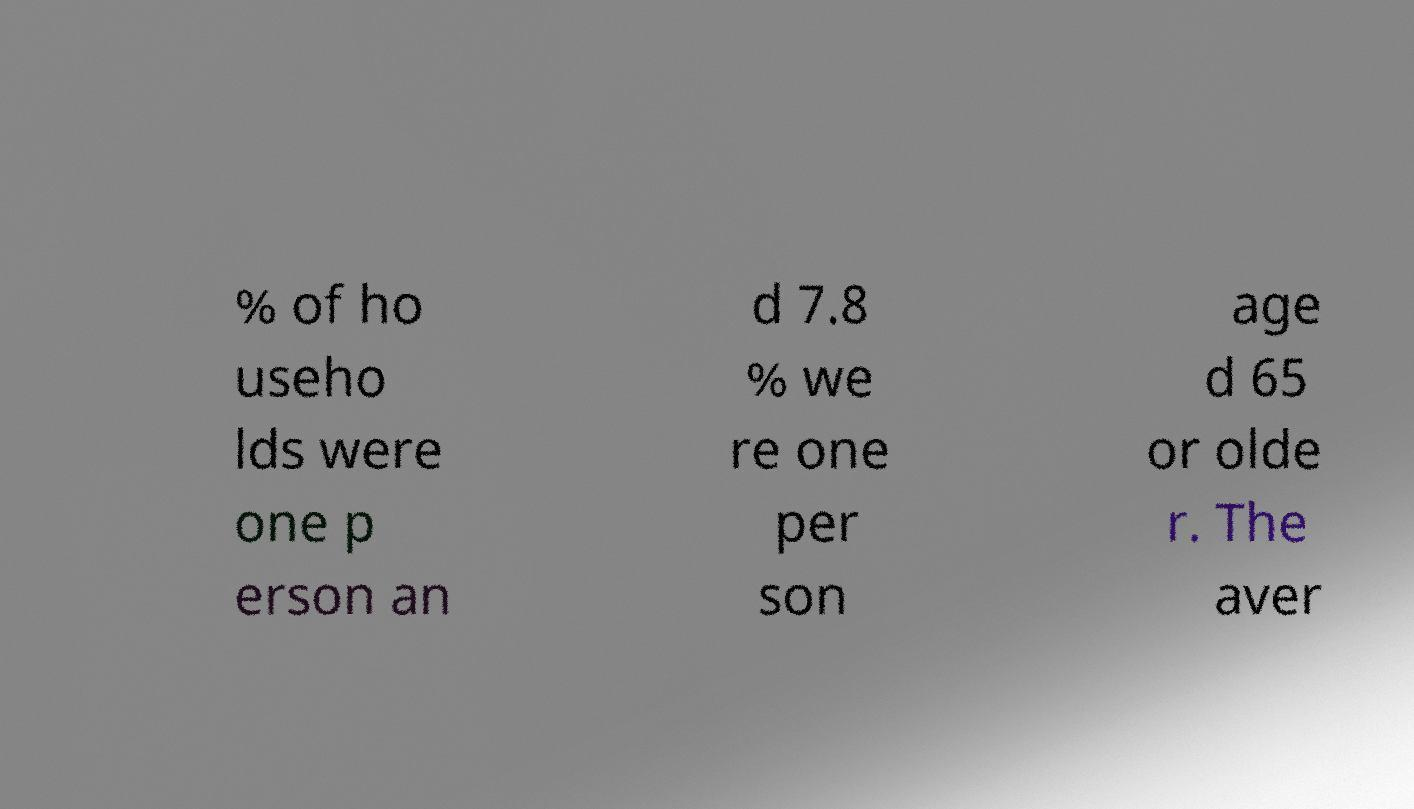Please read and relay the text visible in this image. What does it say? % of ho useho lds were one p erson an d 7.8 % we re one per son age d 65 or olde r. The aver 